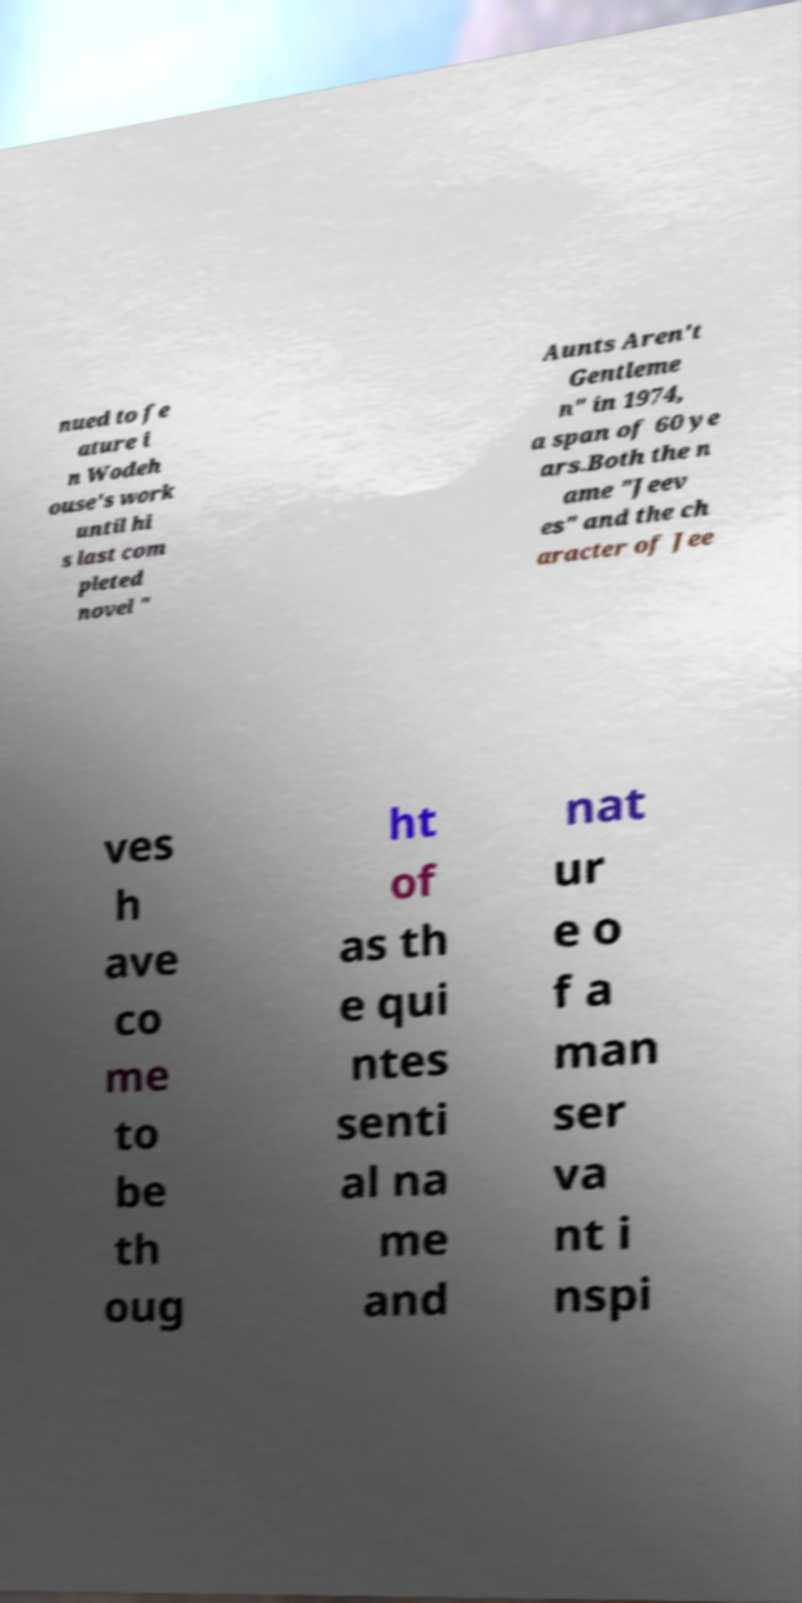I need the written content from this picture converted into text. Can you do that? nued to fe ature i n Wodeh ouse's work until hi s last com pleted novel " Aunts Aren't Gentleme n" in 1974, a span of 60 ye ars.Both the n ame "Jeev es" and the ch aracter of Jee ves h ave co me to be th oug ht of as th e qui ntes senti al na me and nat ur e o f a man ser va nt i nspi 